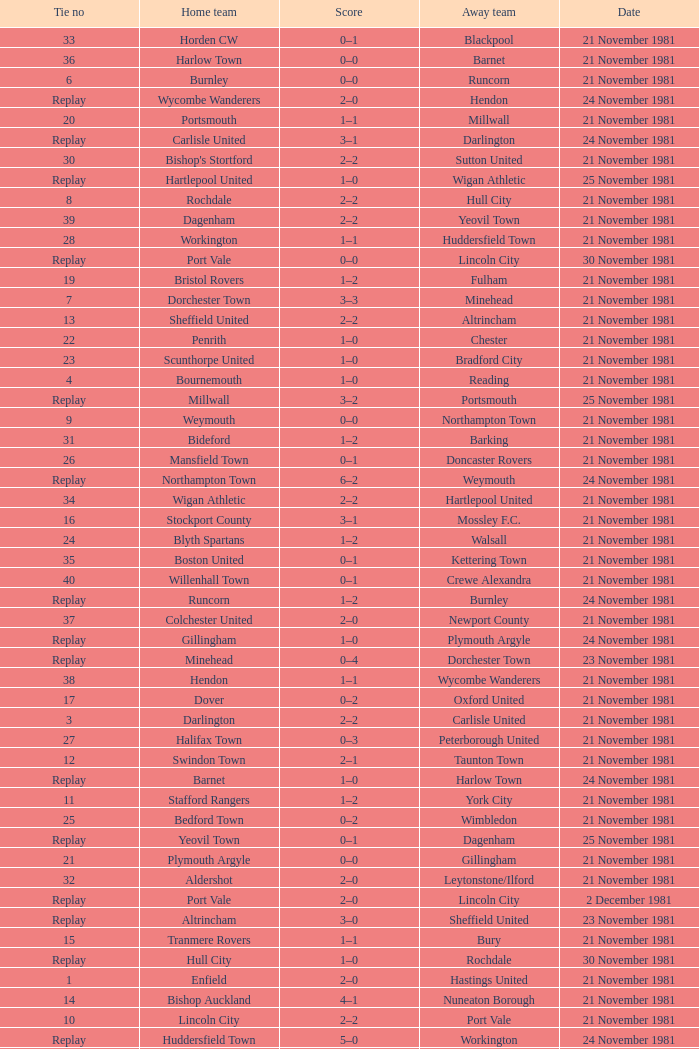What is enfield's tie number? 1.0. Parse the full table. {'header': ['Tie no', 'Home team', 'Score', 'Away team', 'Date'], 'rows': [['33', 'Horden CW', '0–1', 'Blackpool', '21 November 1981'], ['36', 'Harlow Town', '0–0', 'Barnet', '21 November 1981'], ['6', 'Burnley', '0–0', 'Runcorn', '21 November 1981'], ['Replay', 'Wycombe Wanderers', '2–0', 'Hendon', '24 November 1981'], ['20', 'Portsmouth', '1–1', 'Millwall', '21 November 1981'], ['Replay', 'Carlisle United', '3–1', 'Darlington', '24 November 1981'], ['30', "Bishop's Stortford", '2–2', 'Sutton United', '21 November 1981'], ['Replay', 'Hartlepool United', '1–0', 'Wigan Athletic', '25 November 1981'], ['8', 'Rochdale', '2–2', 'Hull City', '21 November 1981'], ['39', 'Dagenham', '2–2', 'Yeovil Town', '21 November 1981'], ['28', 'Workington', '1–1', 'Huddersfield Town', '21 November 1981'], ['Replay', 'Port Vale', '0–0', 'Lincoln City', '30 November 1981'], ['19', 'Bristol Rovers', '1–2', 'Fulham', '21 November 1981'], ['7', 'Dorchester Town', '3–3', 'Minehead', '21 November 1981'], ['13', 'Sheffield United', '2–2', 'Altrincham', '21 November 1981'], ['22', 'Penrith', '1–0', 'Chester', '21 November 1981'], ['23', 'Scunthorpe United', '1–0', 'Bradford City', '21 November 1981'], ['4', 'Bournemouth', '1–0', 'Reading', '21 November 1981'], ['Replay', 'Millwall', '3–2', 'Portsmouth', '25 November 1981'], ['9', 'Weymouth', '0–0', 'Northampton Town', '21 November 1981'], ['31', 'Bideford', '1–2', 'Barking', '21 November 1981'], ['26', 'Mansfield Town', '0–1', 'Doncaster Rovers', '21 November 1981'], ['Replay', 'Northampton Town', '6–2', 'Weymouth', '24 November 1981'], ['34', 'Wigan Athletic', '2–2', 'Hartlepool United', '21 November 1981'], ['16', 'Stockport County', '3–1', 'Mossley F.C.', '21 November 1981'], ['24', 'Blyth Spartans', '1–2', 'Walsall', '21 November 1981'], ['35', 'Boston United', '0–1', 'Kettering Town', '21 November 1981'], ['40', 'Willenhall Town', '0–1', 'Crewe Alexandra', '21 November 1981'], ['Replay', 'Runcorn', '1–2', 'Burnley', '24 November 1981'], ['37', 'Colchester United', '2–0', 'Newport County', '21 November 1981'], ['Replay', 'Gillingham', '1–0', 'Plymouth Argyle', '24 November 1981'], ['Replay', 'Minehead', '0–4', 'Dorchester Town', '23 November 1981'], ['38', 'Hendon', '1–1', 'Wycombe Wanderers', '21 November 1981'], ['17', 'Dover', '0–2', 'Oxford United', '21 November 1981'], ['3', 'Darlington', '2–2', 'Carlisle United', '21 November 1981'], ['27', 'Halifax Town', '0–3', 'Peterborough United', '21 November 1981'], ['12', 'Swindon Town', '2–1', 'Taunton Town', '21 November 1981'], ['Replay', 'Barnet', '1–0', 'Harlow Town', '24 November 1981'], ['11', 'Stafford Rangers', '1–2', 'York City', '21 November 1981'], ['25', 'Bedford Town', '0–2', 'Wimbledon', '21 November 1981'], ['Replay', 'Yeovil Town', '0–1', 'Dagenham', '25 November 1981'], ['21', 'Plymouth Argyle', '0–0', 'Gillingham', '21 November 1981'], ['32', 'Aldershot', '2–0', 'Leytonstone/Ilford', '21 November 1981'], ['Replay', 'Port Vale', '2–0', 'Lincoln City', '2 December 1981'], ['Replay', 'Altrincham', '3–0', 'Sheffield United', '23 November 1981'], ['15', 'Tranmere Rovers', '1–1', 'Bury', '21 November 1981'], ['Replay', 'Hull City', '1–0', 'Rochdale', '30 November 1981'], ['1', 'Enfield', '2–0', 'Hastings United', '21 November 1981'], ['14', 'Bishop Auckland', '4–1', 'Nuneaton Borough', '21 November 1981'], ['10', 'Lincoln City', '2–2', 'Port Vale', '21 November 1981'], ['Replay', 'Huddersfield Town', '5–0', 'Workington', '24 November 1981'], ['29', 'Hereford United', '3–1', 'Southend United', '21 November 1981'], ['Replay', 'Hull City', '2–2', 'Rochdale', '24 November 1981'], ['5', 'Bristol City', '0–0', 'Torquay United', '20 November 1981'], ['Replay', 'Bury', '3–1', 'Tranmere Rovers', '24 November 1981'], ['Replay', 'Torquay United', '1–2', 'Bristol City', '25 November 1981'], ['2', 'Chesterfield', '4–1', 'Preston North End', '21 November 1981'], ['18', 'Brentford', '2–0', 'Exeter City', '21 November 1981'], ['Replay', 'Sutton United', '2–1', "Bishop's Stortford", '24 November 1981']]} 